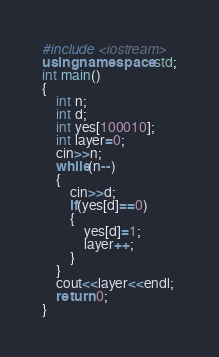<code> <loc_0><loc_0><loc_500><loc_500><_C++_>#include <iostream>
using namespace std;
int main()
{
	int n;
	int d;
	int yes[100010];
	int layer=0;
	cin>>n;
	while(n--)
	{
		cin>>d;
		if(yes[d]==0)
		{
			yes[d]=1;
			layer++;
		}
	}
	cout<<layer<<endl;
	return 0;
}</code> 